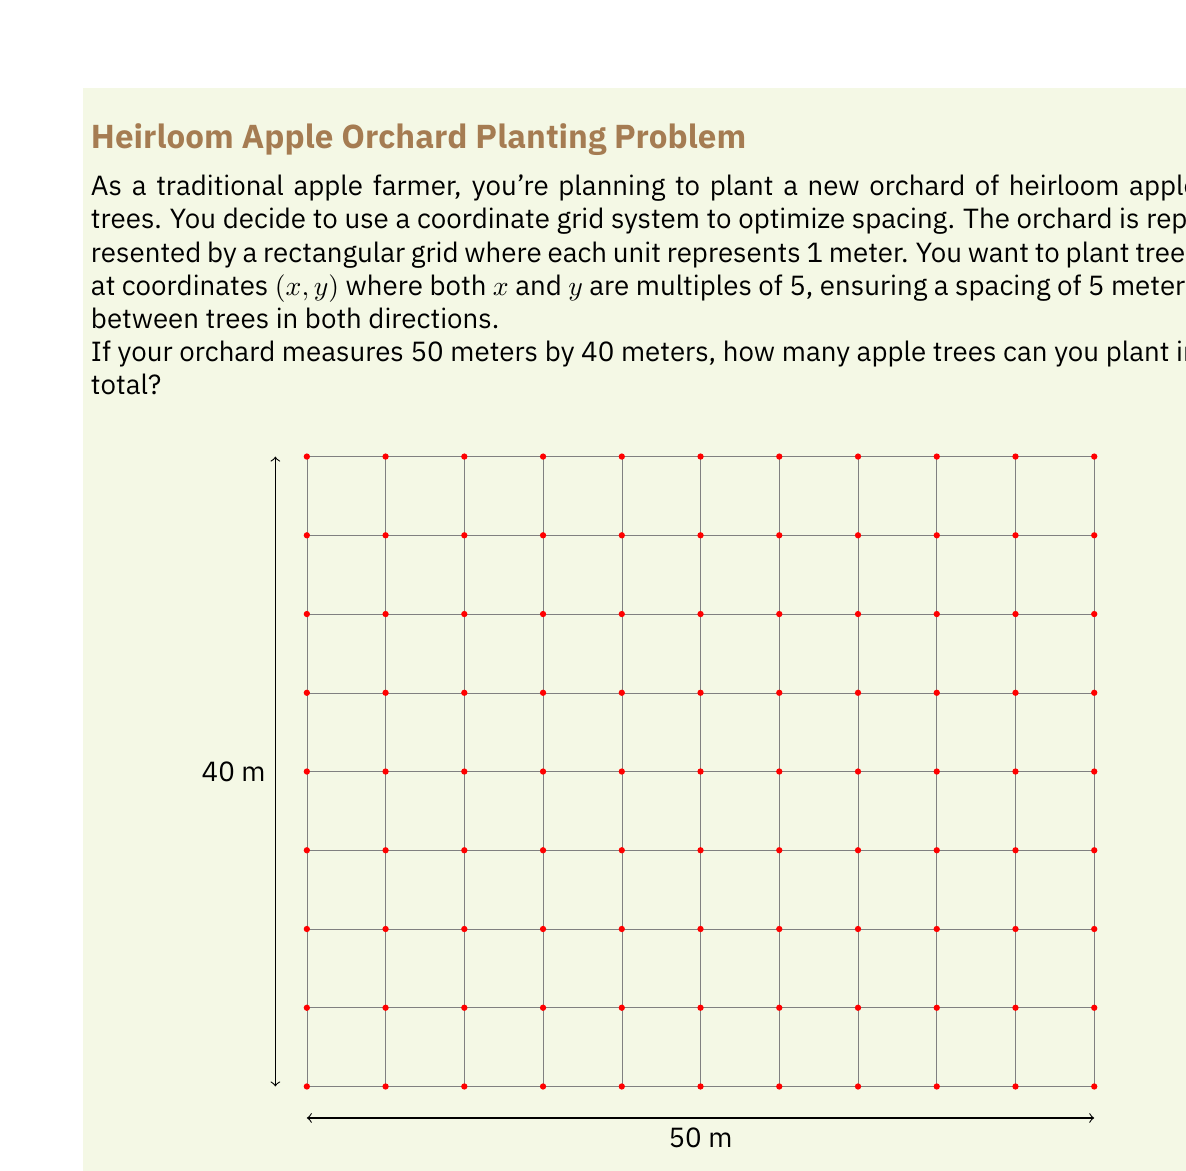Can you answer this question? Let's approach this step-by-step:

1) First, we need to determine how many trees can be planted along the length and width of the orchard.

2) For the length (50 meters):
   - The coordinates will be 0, 5, 10, 15, ..., 50
   - To count these, we can use the formula: $\frac{\text{length}}{\text{spacing}} + 1$
   - Number of trees along length = $\frac{50}{5} + 1 = 10 + 1 = 11$

3) For the width (40 meters):
   - The coordinates will be 0, 5, 10, 15, ..., 40
   - Using the same formula: $\frac{\text{width}}{\text{spacing}} + 1$
   - Number of trees along width = $\frac{40}{5} + 1 = 8 + 1 = 9$

4) Now, to find the total number of trees, we multiply the number of trees along the length by the number of trees along the width:

   Total trees = 11 * 9 = 99

5) We can verify this by counting the red dots in the diagram, which represent the trees.

Therefore, you can plant 99 apple trees in your orchard with this spacing.
Answer: 99 trees 